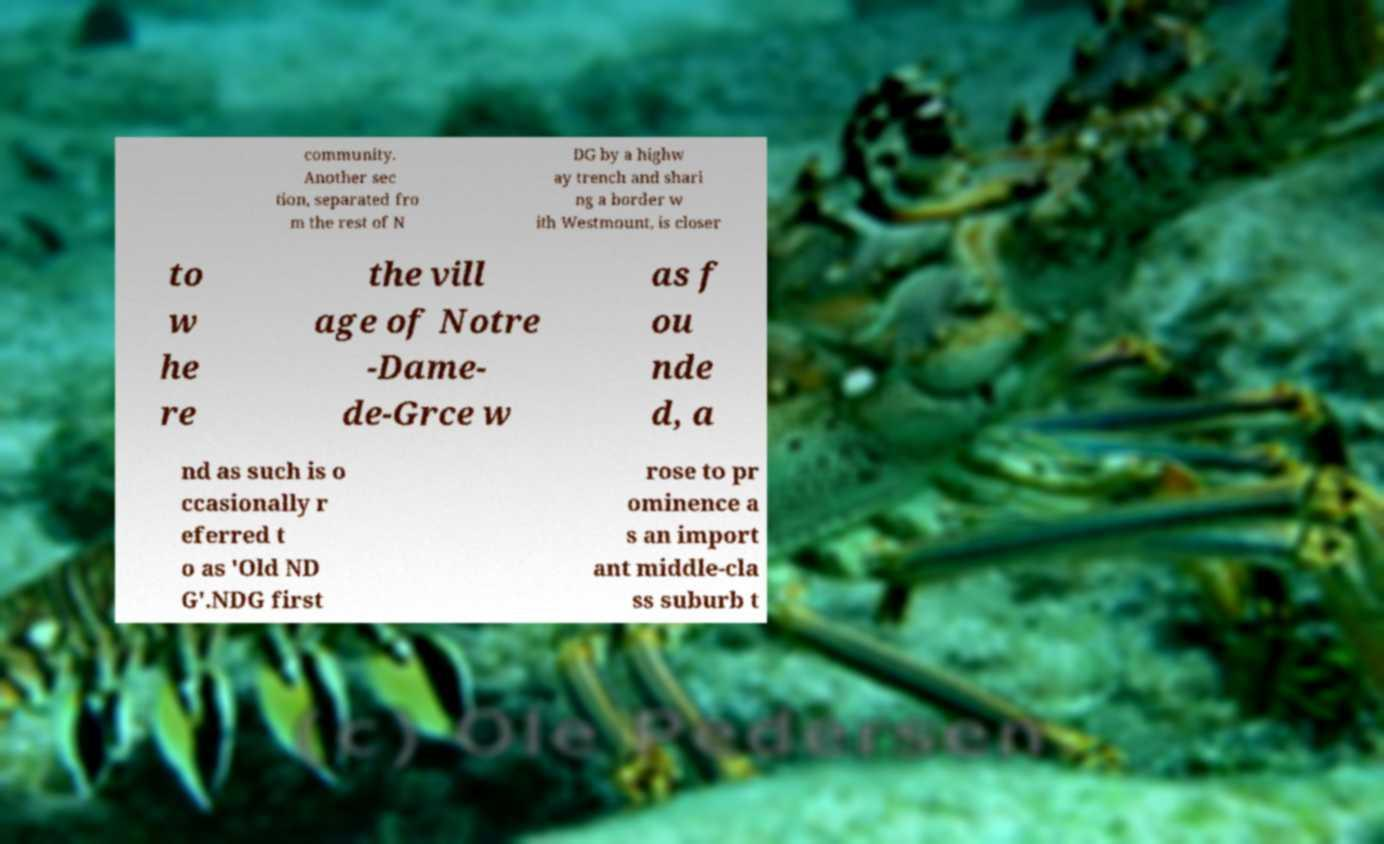There's text embedded in this image that I need extracted. Can you transcribe it verbatim? community. Another sec tion, separated fro m the rest of N DG by a highw ay trench and shari ng a border w ith Westmount, is closer to w he re the vill age of Notre -Dame- de-Grce w as f ou nde d, a nd as such is o ccasionally r eferred t o as 'Old ND G'.NDG first rose to pr ominence a s an import ant middle-cla ss suburb t 